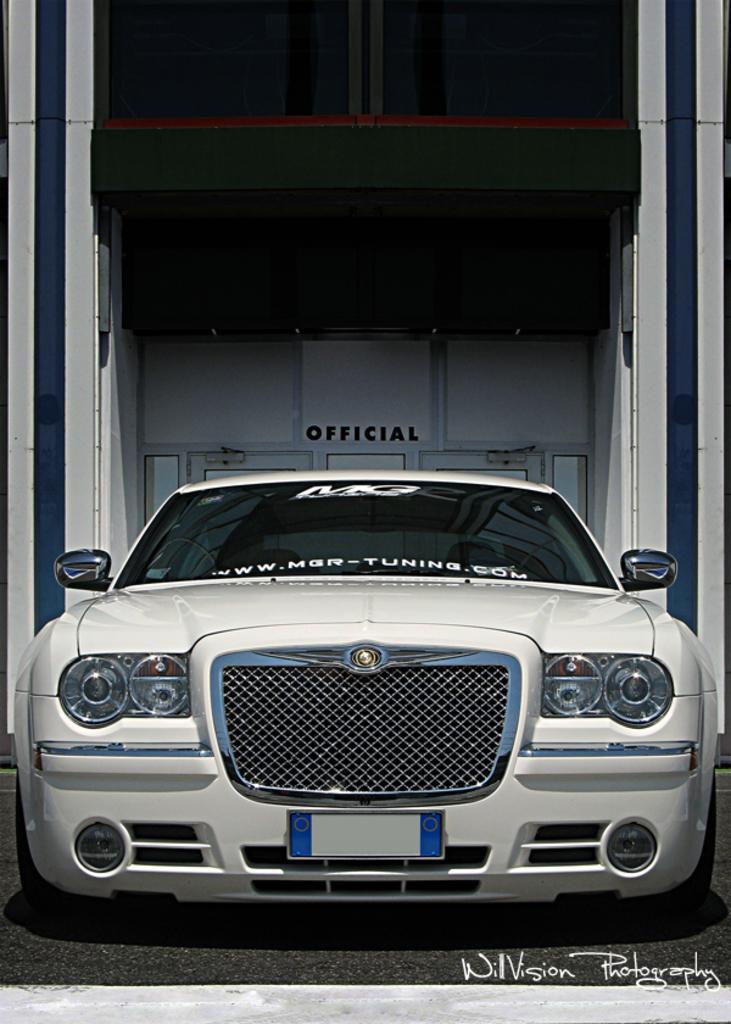Please provide a concise description of this image. In this image in the middle there is a car on the ground. At the bottom there is a text. In the background there is a building and window. 